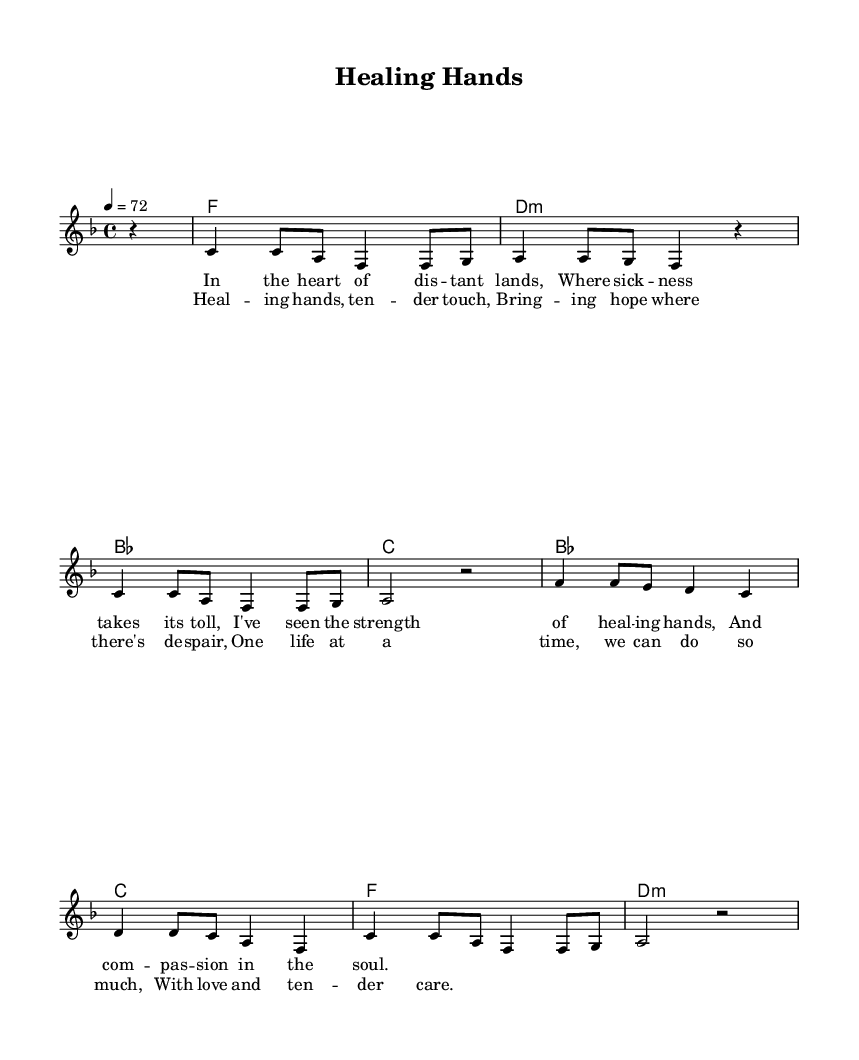What is the key signature of this music? The key signature is indicated at the beginning of the score where the 'f' major key is mentioned. 'F major' has one flat (B flat).
Answer: F major What is the time signature of this music? The time signature is located at the beginning of the score and is indicated as 4/4. This means there are four beats per measure, and the quarter note gets one beat.
Answer: 4/4 What is the tempo marking for this music? The tempo marking is given in beats per minute, where it states '4 = 72', indicating that a quarter note gets 72 beats per minute. This is typically characterized as a moderate tempo.
Answer: 72 How many measures are in the verse? By counting the number of measure lines in the 'verseOne' section, we see there are a total of four measures provided.
Answer: 4 What is the primary theme explored in the lyrics? The lyrics convey themes of healing and compassion, particularly in the context of caring for those who are suffering. The phrases focus on hope and support in times of despair.
Answer: Healing and compassion What chord follows the F major chord? In the chord progression, after the F major chord, the next chord is the D minor chord, which is revealed in the harmonic part of the score that lists out the chords in sequence.
Answer: D minor How is the emotional tone conveyed musically in the chorus? The emotional tone in the chorus is conveyed through the use of uplifting language paired with a tender melody, alongside harmonies that support feelings of hope and care, characteristic of soulful ballads.
Answer: Uplifting tone 